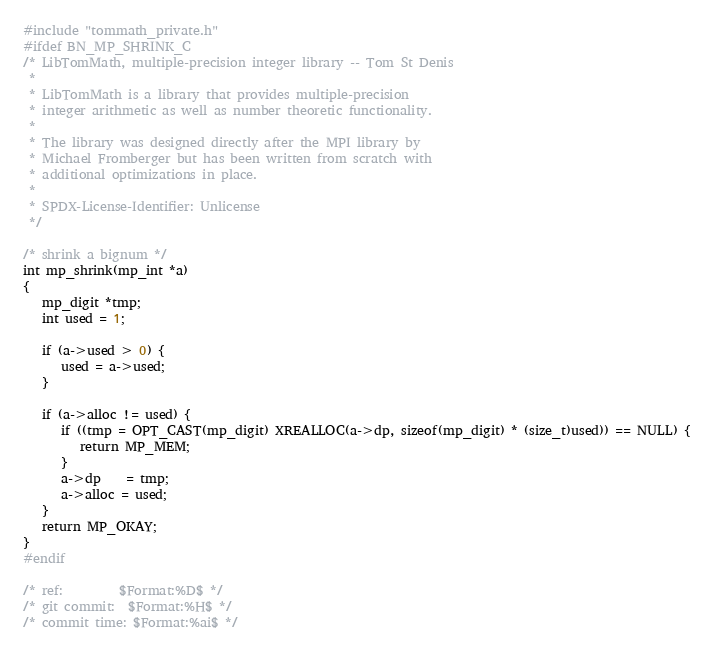<code> <loc_0><loc_0><loc_500><loc_500><_C_>#include "tommath_private.h"
#ifdef BN_MP_SHRINK_C
/* LibTomMath, multiple-precision integer library -- Tom St Denis
 *
 * LibTomMath is a library that provides multiple-precision
 * integer arithmetic as well as number theoretic functionality.
 *
 * The library was designed directly after the MPI library by
 * Michael Fromberger but has been written from scratch with
 * additional optimizations in place.
 *
 * SPDX-License-Identifier: Unlicense
 */

/* shrink a bignum */
int mp_shrink(mp_int *a)
{
   mp_digit *tmp;
   int used = 1;

   if (a->used > 0) {
      used = a->used;
   }

   if (a->alloc != used) {
      if ((tmp = OPT_CAST(mp_digit) XREALLOC(a->dp, sizeof(mp_digit) * (size_t)used)) == NULL) {
         return MP_MEM;
      }
      a->dp    = tmp;
      a->alloc = used;
   }
   return MP_OKAY;
}
#endif

/* ref:         $Format:%D$ */
/* git commit:  $Format:%H$ */
/* commit time: $Format:%ai$ */
</code> 